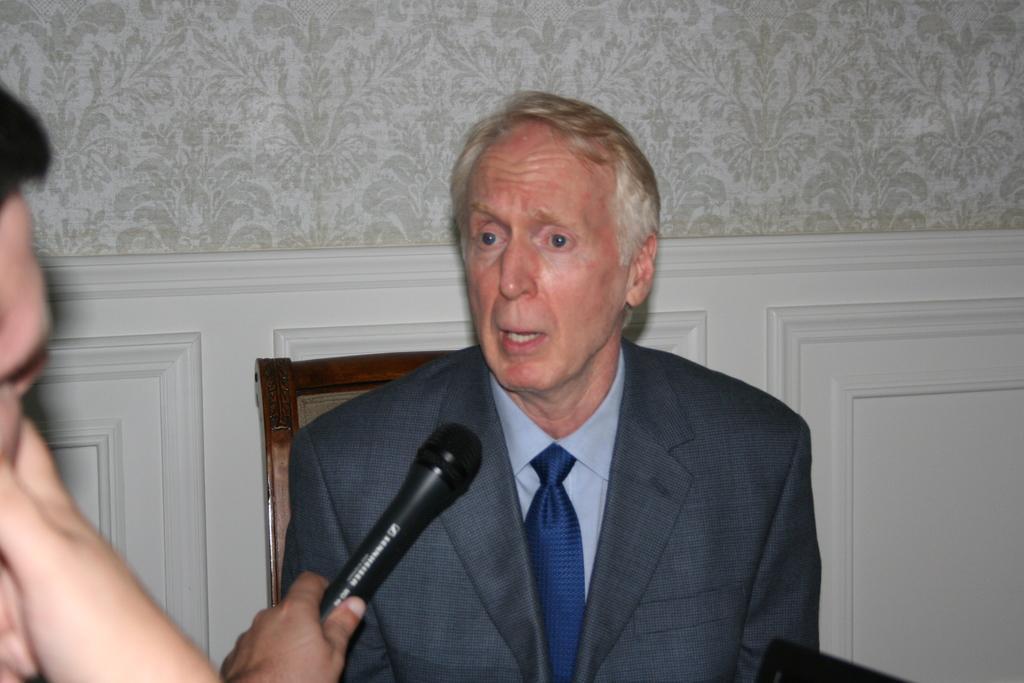Please provide a concise description of this image. In this image we can see a person sitting on a chair. On the left side we can see another person. Also we can see hand of a person with a mic. In the background there is a wall with a design. 